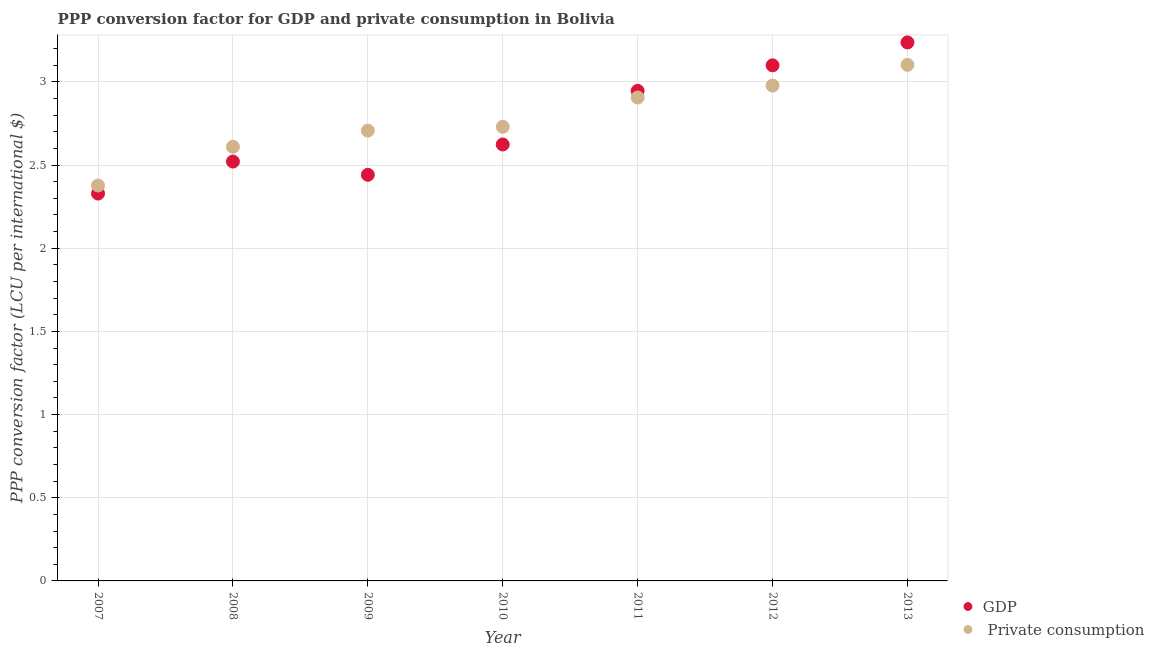How many different coloured dotlines are there?
Your answer should be very brief. 2. What is the ppp conversion factor for private consumption in 2009?
Ensure brevity in your answer.  2.71. Across all years, what is the maximum ppp conversion factor for gdp?
Make the answer very short. 3.24. Across all years, what is the minimum ppp conversion factor for gdp?
Your answer should be compact. 2.33. In which year was the ppp conversion factor for private consumption maximum?
Your response must be concise. 2013. In which year was the ppp conversion factor for gdp minimum?
Your answer should be very brief. 2007. What is the total ppp conversion factor for gdp in the graph?
Provide a short and direct response. 19.2. What is the difference between the ppp conversion factor for private consumption in 2008 and that in 2009?
Your response must be concise. -0.1. What is the difference between the ppp conversion factor for private consumption in 2007 and the ppp conversion factor for gdp in 2010?
Keep it short and to the point. -0.25. What is the average ppp conversion factor for private consumption per year?
Provide a short and direct response. 2.77. In the year 2011, what is the difference between the ppp conversion factor for gdp and ppp conversion factor for private consumption?
Keep it short and to the point. 0.04. What is the ratio of the ppp conversion factor for private consumption in 2008 to that in 2011?
Offer a very short reply. 0.9. What is the difference between the highest and the second highest ppp conversion factor for private consumption?
Offer a terse response. 0.12. What is the difference between the highest and the lowest ppp conversion factor for gdp?
Keep it short and to the point. 0.91. In how many years, is the ppp conversion factor for private consumption greater than the average ppp conversion factor for private consumption taken over all years?
Provide a short and direct response. 3. Does the ppp conversion factor for gdp monotonically increase over the years?
Ensure brevity in your answer.  No. Is the ppp conversion factor for private consumption strictly less than the ppp conversion factor for gdp over the years?
Offer a very short reply. No. How many dotlines are there?
Offer a very short reply. 2. Are the values on the major ticks of Y-axis written in scientific E-notation?
Your answer should be very brief. No. Does the graph contain any zero values?
Provide a short and direct response. No. Where does the legend appear in the graph?
Your response must be concise. Bottom right. What is the title of the graph?
Your response must be concise. PPP conversion factor for GDP and private consumption in Bolivia. What is the label or title of the X-axis?
Give a very brief answer. Year. What is the label or title of the Y-axis?
Ensure brevity in your answer.  PPP conversion factor (LCU per international $). What is the PPP conversion factor (LCU per international $) in GDP in 2007?
Give a very brief answer. 2.33. What is the PPP conversion factor (LCU per international $) in  Private consumption in 2007?
Provide a short and direct response. 2.38. What is the PPP conversion factor (LCU per international $) of GDP in 2008?
Provide a succinct answer. 2.52. What is the PPP conversion factor (LCU per international $) in  Private consumption in 2008?
Ensure brevity in your answer.  2.61. What is the PPP conversion factor (LCU per international $) of GDP in 2009?
Your answer should be very brief. 2.44. What is the PPP conversion factor (LCU per international $) in  Private consumption in 2009?
Give a very brief answer. 2.71. What is the PPP conversion factor (LCU per international $) in GDP in 2010?
Provide a succinct answer. 2.62. What is the PPP conversion factor (LCU per international $) in  Private consumption in 2010?
Provide a succinct answer. 2.73. What is the PPP conversion factor (LCU per international $) of GDP in 2011?
Your response must be concise. 2.95. What is the PPP conversion factor (LCU per international $) in  Private consumption in 2011?
Offer a very short reply. 2.91. What is the PPP conversion factor (LCU per international $) in GDP in 2012?
Provide a short and direct response. 3.1. What is the PPP conversion factor (LCU per international $) in  Private consumption in 2012?
Provide a succinct answer. 2.98. What is the PPP conversion factor (LCU per international $) of GDP in 2013?
Offer a very short reply. 3.24. What is the PPP conversion factor (LCU per international $) in  Private consumption in 2013?
Keep it short and to the point. 3.1. Across all years, what is the maximum PPP conversion factor (LCU per international $) of GDP?
Your response must be concise. 3.24. Across all years, what is the maximum PPP conversion factor (LCU per international $) of  Private consumption?
Ensure brevity in your answer.  3.1. Across all years, what is the minimum PPP conversion factor (LCU per international $) in GDP?
Offer a very short reply. 2.33. Across all years, what is the minimum PPP conversion factor (LCU per international $) in  Private consumption?
Make the answer very short. 2.38. What is the total PPP conversion factor (LCU per international $) of GDP in the graph?
Offer a very short reply. 19.2. What is the total PPP conversion factor (LCU per international $) in  Private consumption in the graph?
Your response must be concise. 19.41. What is the difference between the PPP conversion factor (LCU per international $) in GDP in 2007 and that in 2008?
Offer a terse response. -0.19. What is the difference between the PPP conversion factor (LCU per international $) in  Private consumption in 2007 and that in 2008?
Keep it short and to the point. -0.23. What is the difference between the PPP conversion factor (LCU per international $) in GDP in 2007 and that in 2009?
Your answer should be compact. -0.11. What is the difference between the PPP conversion factor (LCU per international $) of  Private consumption in 2007 and that in 2009?
Your answer should be compact. -0.33. What is the difference between the PPP conversion factor (LCU per international $) of GDP in 2007 and that in 2010?
Provide a short and direct response. -0.29. What is the difference between the PPP conversion factor (LCU per international $) in  Private consumption in 2007 and that in 2010?
Provide a succinct answer. -0.35. What is the difference between the PPP conversion factor (LCU per international $) in GDP in 2007 and that in 2011?
Provide a short and direct response. -0.62. What is the difference between the PPP conversion factor (LCU per international $) in  Private consumption in 2007 and that in 2011?
Your answer should be compact. -0.53. What is the difference between the PPP conversion factor (LCU per international $) of GDP in 2007 and that in 2012?
Provide a short and direct response. -0.77. What is the difference between the PPP conversion factor (LCU per international $) of  Private consumption in 2007 and that in 2012?
Make the answer very short. -0.6. What is the difference between the PPP conversion factor (LCU per international $) of GDP in 2007 and that in 2013?
Offer a very short reply. -0.91. What is the difference between the PPP conversion factor (LCU per international $) of  Private consumption in 2007 and that in 2013?
Offer a very short reply. -0.73. What is the difference between the PPP conversion factor (LCU per international $) of GDP in 2008 and that in 2009?
Offer a terse response. 0.08. What is the difference between the PPP conversion factor (LCU per international $) of  Private consumption in 2008 and that in 2009?
Ensure brevity in your answer.  -0.1. What is the difference between the PPP conversion factor (LCU per international $) in GDP in 2008 and that in 2010?
Provide a succinct answer. -0.1. What is the difference between the PPP conversion factor (LCU per international $) in  Private consumption in 2008 and that in 2010?
Offer a very short reply. -0.12. What is the difference between the PPP conversion factor (LCU per international $) in GDP in 2008 and that in 2011?
Your answer should be very brief. -0.42. What is the difference between the PPP conversion factor (LCU per international $) in  Private consumption in 2008 and that in 2011?
Provide a short and direct response. -0.3. What is the difference between the PPP conversion factor (LCU per international $) in GDP in 2008 and that in 2012?
Offer a very short reply. -0.58. What is the difference between the PPP conversion factor (LCU per international $) in  Private consumption in 2008 and that in 2012?
Make the answer very short. -0.37. What is the difference between the PPP conversion factor (LCU per international $) in GDP in 2008 and that in 2013?
Make the answer very short. -0.72. What is the difference between the PPP conversion factor (LCU per international $) of  Private consumption in 2008 and that in 2013?
Offer a very short reply. -0.49. What is the difference between the PPP conversion factor (LCU per international $) of GDP in 2009 and that in 2010?
Provide a short and direct response. -0.18. What is the difference between the PPP conversion factor (LCU per international $) of  Private consumption in 2009 and that in 2010?
Provide a short and direct response. -0.02. What is the difference between the PPP conversion factor (LCU per international $) in GDP in 2009 and that in 2011?
Keep it short and to the point. -0.5. What is the difference between the PPP conversion factor (LCU per international $) of  Private consumption in 2009 and that in 2011?
Provide a succinct answer. -0.2. What is the difference between the PPP conversion factor (LCU per international $) in GDP in 2009 and that in 2012?
Ensure brevity in your answer.  -0.66. What is the difference between the PPP conversion factor (LCU per international $) in  Private consumption in 2009 and that in 2012?
Provide a short and direct response. -0.27. What is the difference between the PPP conversion factor (LCU per international $) of GDP in 2009 and that in 2013?
Your response must be concise. -0.8. What is the difference between the PPP conversion factor (LCU per international $) in  Private consumption in 2009 and that in 2013?
Your answer should be compact. -0.4. What is the difference between the PPP conversion factor (LCU per international $) in GDP in 2010 and that in 2011?
Offer a terse response. -0.32. What is the difference between the PPP conversion factor (LCU per international $) in  Private consumption in 2010 and that in 2011?
Provide a succinct answer. -0.18. What is the difference between the PPP conversion factor (LCU per international $) of GDP in 2010 and that in 2012?
Keep it short and to the point. -0.48. What is the difference between the PPP conversion factor (LCU per international $) in  Private consumption in 2010 and that in 2012?
Offer a terse response. -0.25. What is the difference between the PPP conversion factor (LCU per international $) of GDP in 2010 and that in 2013?
Your response must be concise. -0.61. What is the difference between the PPP conversion factor (LCU per international $) in  Private consumption in 2010 and that in 2013?
Offer a terse response. -0.37. What is the difference between the PPP conversion factor (LCU per international $) of GDP in 2011 and that in 2012?
Your answer should be very brief. -0.15. What is the difference between the PPP conversion factor (LCU per international $) of  Private consumption in 2011 and that in 2012?
Your response must be concise. -0.07. What is the difference between the PPP conversion factor (LCU per international $) in GDP in 2011 and that in 2013?
Provide a succinct answer. -0.29. What is the difference between the PPP conversion factor (LCU per international $) of  Private consumption in 2011 and that in 2013?
Give a very brief answer. -0.2. What is the difference between the PPP conversion factor (LCU per international $) of GDP in 2012 and that in 2013?
Your response must be concise. -0.14. What is the difference between the PPP conversion factor (LCU per international $) in  Private consumption in 2012 and that in 2013?
Offer a very short reply. -0.12. What is the difference between the PPP conversion factor (LCU per international $) of GDP in 2007 and the PPP conversion factor (LCU per international $) of  Private consumption in 2008?
Provide a short and direct response. -0.28. What is the difference between the PPP conversion factor (LCU per international $) in GDP in 2007 and the PPP conversion factor (LCU per international $) in  Private consumption in 2009?
Ensure brevity in your answer.  -0.38. What is the difference between the PPP conversion factor (LCU per international $) of GDP in 2007 and the PPP conversion factor (LCU per international $) of  Private consumption in 2010?
Give a very brief answer. -0.4. What is the difference between the PPP conversion factor (LCU per international $) of GDP in 2007 and the PPP conversion factor (LCU per international $) of  Private consumption in 2011?
Offer a very short reply. -0.58. What is the difference between the PPP conversion factor (LCU per international $) in GDP in 2007 and the PPP conversion factor (LCU per international $) in  Private consumption in 2012?
Give a very brief answer. -0.65. What is the difference between the PPP conversion factor (LCU per international $) of GDP in 2007 and the PPP conversion factor (LCU per international $) of  Private consumption in 2013?
Your response must be concise. -0.77. What is the difference between the PPP conversion factor (LCU per international $) in GDP in 2008 and the PPP conversion factor (LCU per international $) in  Private consumption in 2009?
Provide a succinct answer. -0.19. What is the difference between the PPP conversion factor (LCU per international $) in GDP in 2008 and the PPP conversion factor (LCU per international $) in  Private consumption in 2010?
Provide a short and direct response. -0.21. What is the difference between the PPP conversion factor (LCU per international $) of GDP in 2008 and the PPP conversion factor (LCU per international $) of  Private consumption in 2011?
Your answer should be compact. -0.39. What is the difference between the PPP conversion factor (LCU per international $) of GDP in 2008 and the PPP conversion factor (LCU per international $) of  Private consumption in 2012?
Your answer should be compact. -0.46. What is the difference between the PPP conversion factor (LCU per international $) of GDP in 2008 and the PPP conversion factor (LCU per international $) of  Private consumption in 2013?
Ensure brevity in your answer.  -0.58. What is the difference between the PPP conversion factor (LCU per international $) in GDP in 2009 and the PPP conversion factor (LCU per international $) in  Private consumption in 2010?
Offer a very short reply. -0.29. What is the difference between the PPP conversion factor (LCU per international $) of GDP in 2009 and the PPP conversion factor (LCU per international $) of  Private consumption in 2011?
Provide a short and direct response. -0.46. What is the difference between the PPP conversion factor (LCU per international $) of GDP in 2009 and the PPP conversion factor (LCU per international $) of  Private consumption in 2012?
Make the answer very short. -0.54. What is the difference between the PPP conversion factor (LCU per international $) in GDP in 2009 and the PPP conversion factor (LCU per international $) in  Private consumption in 2013?
Make the answer very short. -0.66. What is the difference between the PPP conversion factor (LCU per international $) of GDP in 2010 and the PPP conversion factor (LCU per international $) of  Private consumption in 2011?
Provide a succinct answer. -0.28. What is the difference between the PPP conversion factor (LCU per international $) of GDP in 2010 and the PPP conversion factor (LCU per international $) of  Private consumption in 2012?
Your response must be concise. -0.35. What is the difference between the PPP conversion factor (LCU per international $) in GDP in 2010 and the PPP conversion factor (LCU per international $) in  Private consumption in 2013?
Make the answer very short. -0.48. What is the difference between the PPP conversion factor (LCU per international $) of GDP in 2011 and the PPP conversion factor (LCU per international $) of  Private consumption in 2012?
Your answer should be very brief. -0.03. What is the difference between the PPP conversion factor (LCU per international $) in GDP in 2011 and the PPP conversion factor (LCU per international $) in  Private consumption in 2013?
Your response must be concise. -0.16. What is the difference between the PPP conversion factor (LCU per international $) in GDP in 2012 and the PPP conversion factor (LCU per international $) in  Private consumption in 2013?
Provide a short and direct response. -0. What is the average PPP conversion factor (LCU per international $) of GDP per year?
Offer a very short reply. 2.74. What is the average PPP conversion factor (LCU per international $) in  Private consumption per year?
Your answer should be compact. 2.77. In the year 2007, what is the difference between the PPP conversion factor (LCU per international $) in GDP and PPP conversion factor (LCU per international $) in  Private consumption?
Your answer should be compact. -0.05. In the year 2008, what is the difference between the PPP conversion factor (LCU per international $) of GDP and PPP conversion factor (LCU per international $) of  Private consumption?
Make the answer very short. -0.09. In the year 2009, what is the difference between the PPP conversion factor (LCU per international $) of GDP and PPP conversion factor (LCU per international $) of  Private consumption?
Ensure brevity in your answer.  -0.27. In the year 2010, what is the difference between the PPP conversion factor (LCU per international $) in GDP and PPP conversion factor (LCU per international $) in  Private consumption?
Make the answer very short. -0.11. In the year 2011, what is the difference between the PPP conversion factor (LCU per international $) of GDP and PPP conversion factor (LCU per international $) of  Private consumption?
Keep it short and to the point. 0.04. In the year 2012, what is the difference between the PPP conversion factor (LCU per international $) of GDP and PPP conversion factor (LCU per international $) of  Private consumption?
Give a very brief answer. 0.12. In the year 2013, what is the difference between the PPP conversion factor (LCU per international $) of GDP and PPP conversion factor (LCU per international $) of  Private consumption?
Offer a terse response. 0.13. What is the ratio of the PPP conversion factor (LCU per international $) of GDP in 2007 to that in 2008?
Make the answer very short. 0.92. What is the ratio of the PPP conversion factor (LCU per international $) of  Private consumption in 2007 to that in 2008?
Provide a short and direct response. 0.91. What is the ratio of the PPP conversion factor (LCU per international $) in GDP in 2007 to that in 2009?
Your answer should be compact. 0.95. What is the ratio of the PPP conversion factor (LCU per international $) in  Private consumption in 2007 to that in 2009?
Provide a succinct answer. 0.88. What is the ratio of the PPP conversion factor (LCU per international $) of GDP in 2007 to that in 2010?
Make the answer very short. 0.89. What is the ratio of the PPP conversion factor (LCU per international $) in  Private consumption in 2007 to that in 2010?
Your response must be concise. 0.87. What is the ratio of the PPP conversion factor (LCU per international $) in GDP in 2007 to that in 2011?
Your answer should be compact. 0.79. What is the ratio of the PPP conversion factor (LCU per international $) in  Private consumption in 2007 to that in 2011?
Your response must be concise. 0.82. What is the ratio of the PPP conversion factor (LCU per international $) in GDP in 2007 to that in 2012?
Your answer should be very brief. 0.75. What is the ratio of the PPP conversion factor (LCU per international $) in  Private consumption in 2007 to that in 2012?
Keep it short and to the point. 0.8. What is the ratio of the PPP conversion factor (LCU per international $) in GDP in 2007 to that in 2013?
Offer a terse response. 0.72. What is the ratio of the PPP conversion factor (LCU per international $) of  Private consumption in 2007 to that in 2013?
Give a very brief answer. 0.77. What is the ratio of the PPP conversion factor (LCU per international $) in GDP in 2008 to that in 2009?
Ensure brevity in your answer.  1.03. What is the ratio of the PPP conversion factor (LCU per international $) of  Private consumption in 2008 to that in 2009?
Make the answer very short. 0.96. What is the ratio of the PPP conversion factor (LCU per international $) of GDP in 2008 to that in 2010?
Give a very brief answer. 0.96. What is the ratio of the PPP conversion factor (LCU per international $) in  Private consumption in 2008 to that in 2010?
Provide a short and direct response. 0.96. What is the ratio of the PPP conversion factor (LCU per international $) of GDP in 2008 to that in 2011?
Make the answer very short. 0.86. What is the ratio of the PPP conversion factor (LCU per international $) of  Private consumption in 2008 to that in 2011?
Your response must be concise. 0.9. What is the ratio of the PPP conversion factor (LCU per international $) in GDP in 2008 to that in 2012?
Offer a very short reply. 0.81. What is the ratio of the PPP conversion factor (LCU per international $) of  Private consumption in 2008 to that in 2012?
Offer a terse response. 0.88. What is the ratio of the PPP conversion factor (LCU per international $) of GDP in 2008 to that in 2013?
Offer a terse response. 0.78. What is the ratio of the PPP conversion factor (LCU per international $) of  Private consumption in 2008 to that in 2013?
Give a very brief answer. 0.84. What is the ratio of the PPP conversion factor (LCU per international $) in GDP in 2009 to that in 2010?
Your response must be concise. 0.93. What is the ratio of the PPP conversion factor (LCU per international $) of GDP in 2009 to that in 2011?
Provide a succinct answer. 0.83. What is the ratio of the PPP conversion factor (LCU per international $) of  Private consumption in 2009 to that in 2011?
Your answer should be compact. 0.93. What is the ratio of the PPP conversion factor (LCU per international $) of GDP in 2009 to that in 2012?
Your response must be concise. 0.79. What is the ratio of the PPP conversion factor (LCU per international $) in  Private consumption in 2009 to that in 2012?
Provide a succinct answer. 0.91. What is the ratio of the PPP conversion factor (LCU per international $) of GDP in 2009 to that in 2013?
Offer a terse response. 0.75. What is the ratio of the PPP conversion factor (LCU per international $) of  Private consumption in 2009 to that in 2013?
Make the answer very short. 0.87. What is the ratio of the PPP conversion factor (LCU per international $) of GDP in 2010 to that in 2011?
Ensure brevity in your answer.  0.89. What is the ratio of the PPP conversion factor (LCU per international $) of  Private consumption in 2010 to that in 2011?
Your response must be concise. 0.94. What is the ratio of the PPP conversion factor (LCU per international $) of GDP in 2010 to that in 2012?
Offer a very short reply. 0.85. What is the ratio of the PPP conversion factor (LCU per international $) of  Private consumption in 2010 to that in 2012?
Provide a short and direct response. 0.92. What is the ratio of the PPP conversion factor (LCU per international $) of GDP in 2010 to that in 2013?
Provide a succinct answer. 0.81. What is the ratio of the PPP conversion factor (LCU per international $) in  Private consumption in 2010 to that in 2013?
Your answer should be compact. 0.88. What is the ratio of the PPP conversion factor (LCU per international $) of GDP in 2011 to that in 2012?
Your answer should be compact. 0.95. What is the ratio of the PPP conversion factor (LCU per international $) of  Private consumption in 2011 to that in 2012?
Offer a very short reply. 0.98. What is the ratio of the PPP conversion factor (LCU per international $) of GDP in 2011 to that in 2013?
Your answer should be very brief. 0.91. What is the ratio of the PPP conversion factor (LCU per international $) in  Private consumption in 2011 to that in 2013?
Provide a succinct answer. 0.94. What is the ratio of the PPP conversion factor (LCU per international $) of GDP in 2012 to that in 2013?
Keep it short and to the point. 0.96. What is the ratio of the PPP conversion factor (LCU per international $) in  Private consumption in 2012 to that in 2013?
Your answer should be compact. 0.96. What is the difference between the highest and the second highest PPP conversion factor (LCU per international $) of GDP?
Ensure brevity in your answer.  0.14. What is the difference between the highest and the second highest PPP conversion factor (LCU per international $) of  Private consumption?
Your answer should be compact. 0.12. What is the difference between the highest and the lowest PPP conversion factor (LCU per international $) of GDP?
Offer a very short reply. 0.91. What is the difference between the highest and the lowest PPP conversion factor (LCU per international $) in  Private consumption?
Offer a very short reply. 0.73. 